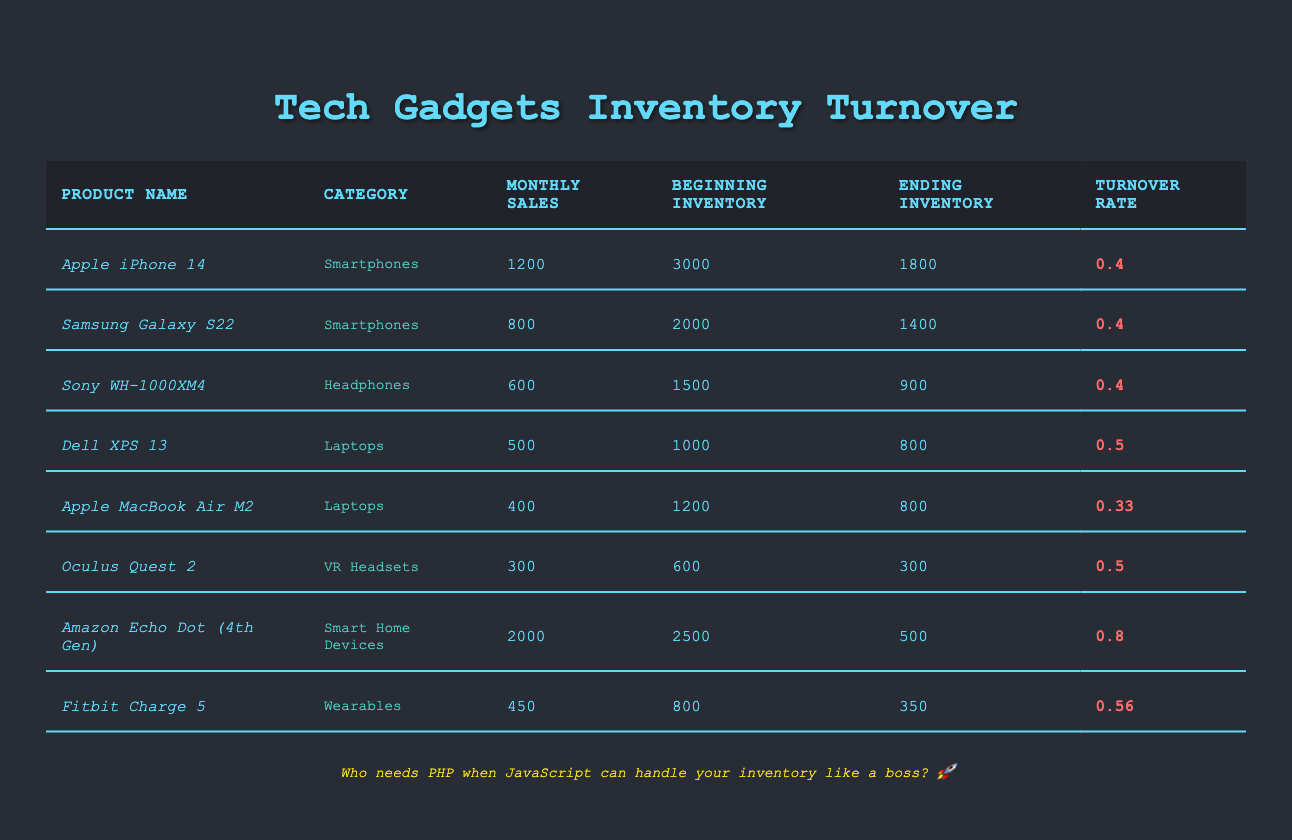What is the turnover rate of the Apple iPhone 14? The turnover rate for the Apple iPhone 14 is listed in the table under the "Turnover Rate" column, which shows 0.4.
Answer: 0.4 How many monthly sales does the Amazon Echo Dot (4th Gen) have? The monthly sales for the Amazon Echo Dot (4th Gen) can be found in the "Monthly Sales" column, showing a value of 2000.
Answer: 2000 Is the turnover rate for the Dell XPS 13 higher than that of the Apple MacBook Air M2? The turnover rate for the Dell XPS 13 is 0.5, while that for the Apple MacBook Air M2 is 0.33. Since 0.5 is greater than 0.33, the statement is true.
Answer: Yes What is the average turnover rate of all products listed in the table? To find the average turnover rate, sum all turnover rates (0.4 + 0.4 + 0.4 + 0.5 + 0.33 + 0.5 + 0.8 + 0.56 = 3.93) and divide by the number of products (8). Thus, 3.93/8 = 0.49125, which rounds to 0.49.
Answer: 0.49 Which product has the highest monthly sales? By checking the "Monthly Sales" column, the product with the highest value appears to be the Amazon Echo Dot (4th Gen) with 2000 monthly sales.
Answer: Amazon Echo Dot (4th Gen) How many total monthly sales are there for all wearables listed? The only wearable listed is the Fitbit Charge 5, which has monthly sales of 450. Therefore, total monthly sales for wearables is 450.
Answer: 450 Does the Oculus Quest 2 have a higher beginning inventory than the Sony WH-1000XM4? The beginning inventory for the Oculus Quest 2 is 600, and for the Sony WH-1000XM4, it is 1500. Since 600 is less than 1500, the statement is false.
Answer: No What is the difference in monthly sales between the Apple iPhone 14 and the Samsung Galaxy S22? The monthly sales for the Apple iPhone 14 is 1200, and for the Samsung Galaxy S22, it is 800. The difference is calculated as 1200 - 800 = 400.
Answer: 400 